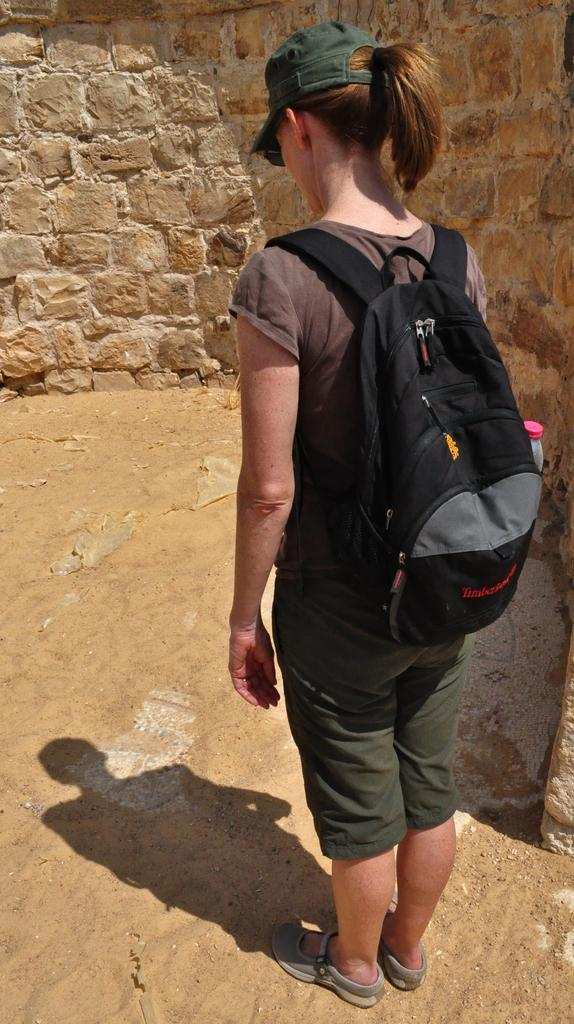Who is present in the image? There is a woman in the image. What is the woman carrying on her back? The woman is carrying a black bag on her back. What is the woman's facial expression or focus in the image? The woman is looking down. What can be seen in front of the woman? There is a wall and sand in front of the woman. What is the chance of lizards appearing in the image? There are no lizards present in the image, so it's not possible to determine the chance of them appearing. 